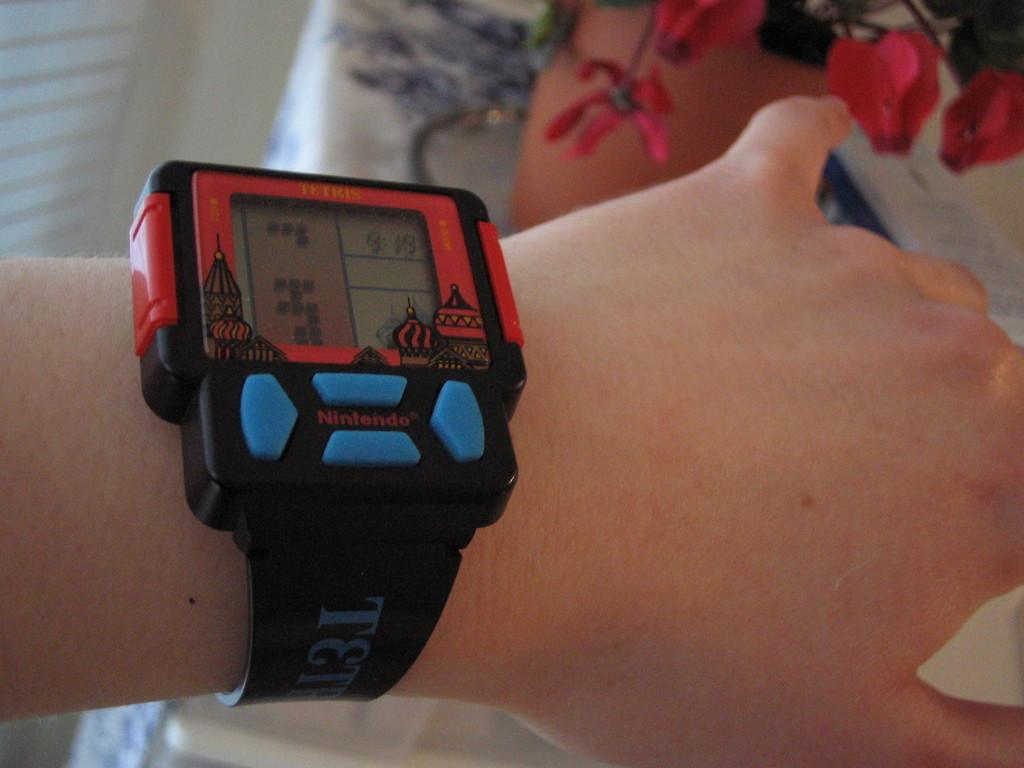<image>
Write a terse but informative summary of the picture. Person wearing a watch that says the word Nintendo on it. 